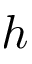Convert formula to latex. <formula><loc_0><loc_0><loc_500><loc_500>h</formula> 